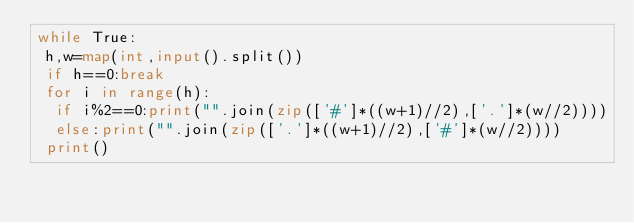<code> <loc_0><loc_0><loc_500><loc_500><_Python_>while True:
 h,w=map(int,input().split())
 if h==0:break
 for i in range(h):
  if i%2==0:print("".join(zip(['#']*((w+1)//2),['.']*(w//2))))
  else:print("".join(zip(['.']*((w+1)//2),['#']*(w//2))))
 print()</code> 